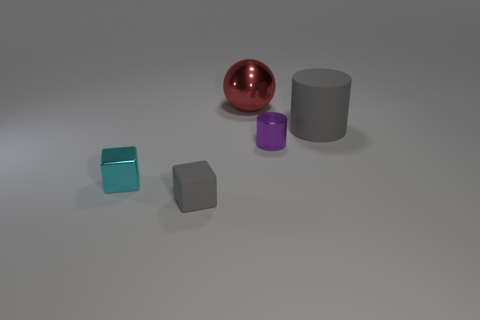There is a gray thing that is on the right side of the tiny gray matte cube; is it the same shape as the tiny thing right of the tiny gray thing? yes 